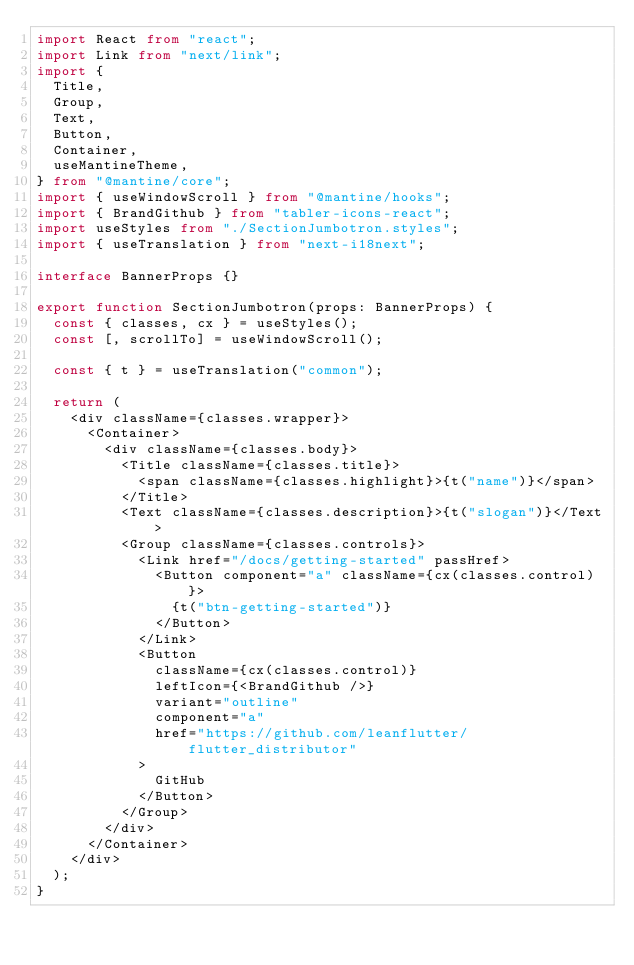Convert code to text. <code><loc_0><loc_0><loc_500><loc_500><_TypeScript_>import React from "react";
import Link from "next/link";
import {
  Title,
  Group,
  Text,
  Button,
  Container,
  useMantineTheme,
} from "@mantine/core";
import { useWindowScroll } from "@mantine/hooks";
import { BrandGithub } from "tabler-icons-react";
import useStyles from "./SectionJumbotron.styles";
import { useTranslation } from "next-i18next";

interface BannerProps {}

export function SectionJumbotron(props: BannerProps) {
  const { classes, cx } = useStyles();
  const [, scrollTo] = useWindowScroll();

  const { t } = useTranslation("common");

  return (
    <div className={classes.wrapper}>
      <Container>
        <div className={classes.body}>
          <Title className={classes.title}>
            <span className={classes.highlight}>{t("name")}</span>
          </Title>
          <Text className={classes.description}>{t("slogan")}</Text>
          <Group className={classes.controls}>
            <Link href="/docs/getting-started" passHref>
              <Button component="a" className={cx(classes.control)}>
                {t("btn-getting-started")}
              </Button>
            </Link>
            <Button
              className={cx(classes.control)}
              leftIcon={<BrandGithub />}
              variant="outline"
              component="a"
              href="https://github.com/leanflutter/flutter_distributor"
            >
              GitHub
            </Button>
          </Group>
        </div>
      </Container>
    </div>
  );
}
</code> 